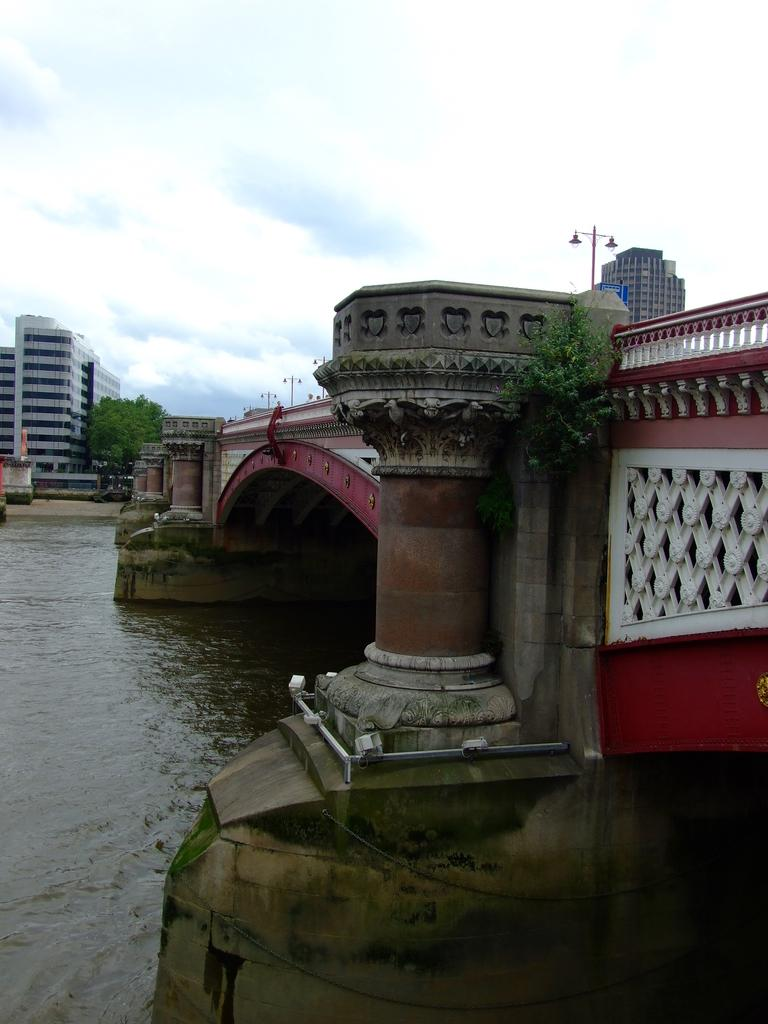What can be seen in the background of the image? In the background of the image, there is a sky, buildings, and a tree. What type of artificial structures are present in the image? There are lights, poles, and pillars in the image. What natural element is visible in the image? Water is visible in the image. What else can be found in the image? There are objects and the formation of algae present in the image. Where is the flock of birds located in the image? There is no flock of birds present in the image. What type of park can be seen in the image? There is no park present in the image. 